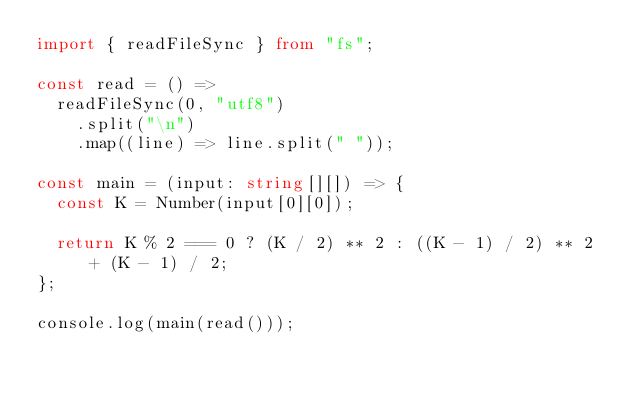<code> <loc_0><loc_0><loc_500><loc_500><_TypeScript_>import { readFileSync } from "fs";

const read = () =>
  readFileSync(0, "utf8")
    .split("\n")
    .map((line) => line.split(" "));

const main = (input: string[][]) => {
  const K = Number(input[0][0]);

  return K % 2 === 0 ? (K / 2) ** 2 : ((K - 1) / 2) ** 2 + (K - 1) / 2;
};

console.log(main(read()));
</code> 